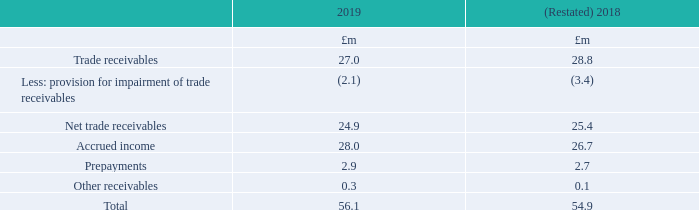18. Trade and other receivables
Following the application of IFRS 16, trade and other receivables have been restated (note 2).
Trade receivables are amounts due from customers for services performed in the ordinary course of business. They are generally due for settlement within 30 days and therefore are all classified as current. Trade receivables are recognised initially at the amount of consideration that is unconditional and has been invoiced at the reporting date. The Group holds the trade receivables with the objective to collect the contractual cash flows and therefore measures them subsequently at amortised cost using the effective interest method.
Accrued income relates to the Group’s rights to consideration for services provided but not invoiced at the reporting date. Accrued income is transferred to receivables when invoiced. Other receivables include £0.1m due from Auto Trader Auto Stock Limited, a related party (note 34).
Exposure credit risk and expected credit losses relating to trade and other receivables are disclosed in note 31.
What are trade receivables? Amounts due from customers for services performed in the ordinary course of business. What does accrued income relate to? The group’s rights to consideration for services provided but not invoiced at the reporting date. What are the components factored in when calculating the net trade receivables? Trade receivables, less: provision for impairment of trade receivables. What was the change in Prepayments in 2019 from 2018?
Answer scale should be: million. 2.9-2.7
Answer: 0.2. What was the percentage change in Prepayments in 2019 from 2018?
Answer scale should be: percent. (2.9-2.7)/2.7
Answer: 7.41. In which year was total trade receivables larger? 56.1>54.9
Answer: 2019. 